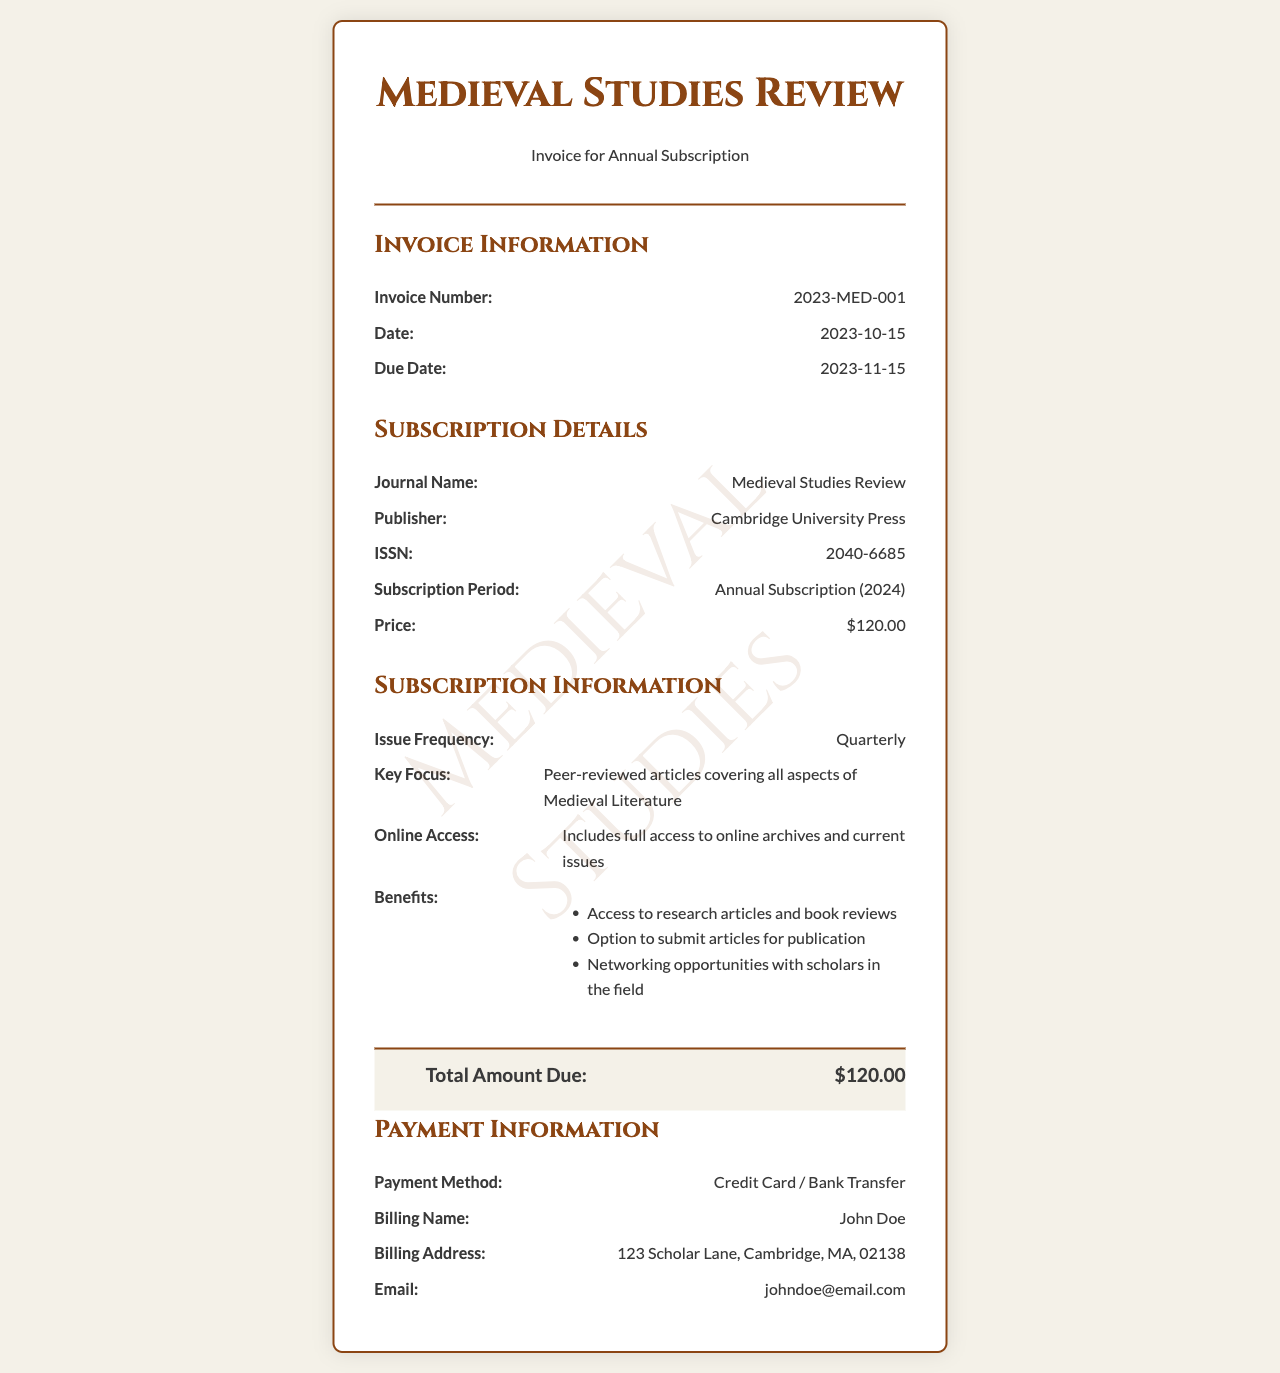What is the invoice number? The invoice number is a unique identifier for the transaction, detailed under "Invoice Information."
Answer: 2023-MED-001 When is the due date for payment? The due date indicates when the invoice must be paid, found in the "Invoice Information" section.
Answer: 2023-11-15 What is the price of the subscription? The price is specified under "Subscription Details," reflecting the cost of the annual subscription.
Answer: $120.00 Who is the publisher of the journal? The publisher's name appears in the "Subscription Details," identifying who produces the journal.
Answer: Cambridge University Press What is the key focus of the journal? The key focus describes the content emphasis and is located in the "Subscription Information" section.
Answer: Peer-reviewed articles covering all aspects of Medieval Literature How often is the journal published? The issue frequency is listed under "Subscription Information," indicating how frequently the journal is released.
Answer: Quarterly What payment methods are accepted? Accepted payment methods are highlighted in the "Payment Information" section of the invoice.
Answer: Credit Card / Bank Transfer What is included with the online access? Information about what online access entails is mentioned under "Subscription Information."
Answer: full access to online archives and current issues What benefits come with the subscription? Benefits are listed as perks of the subscription, provided in a bulleted format in the "Subscription Information."
Answer: Access to research articles and book reviews, Option to submit articles for publication, Networking opportunities with scholars in the field 